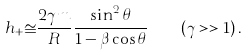<formula> <loc_0><loc_0><loc_500><loc_500>h _ { + } \cong \frac { 2 \gamma m } { R } \frac { { \sin ^ { 2 } \theta } } { 1 - \beta \cos \theta } \quad ( \gamma > > 1 ) \, .</formula> 